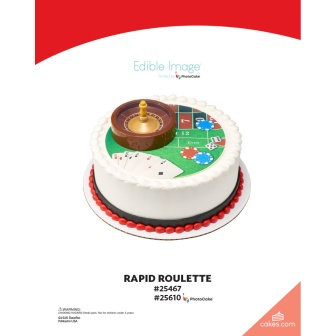If this cake could tell a story, what would it be? Once upon a time, in the heart of a bustling casino, there was a roulette wheel renowned for its ability to change fates with a single spin. Nights would sparkle, filled with the cheers of winners and the concentrated silence of hopefuls. One night, as the casino doors were locked and lights dimmed, a magical pastry chef whisked in. With a sprinkle of sugar and a dash of charm, the roulette wheel transformed into a magnificent cake. This cake captured all the thrill and allure of the roulette game, becoming a beloved centerpiece at grand parties where it shared tales of fortune and celebration with each delicious bite. 